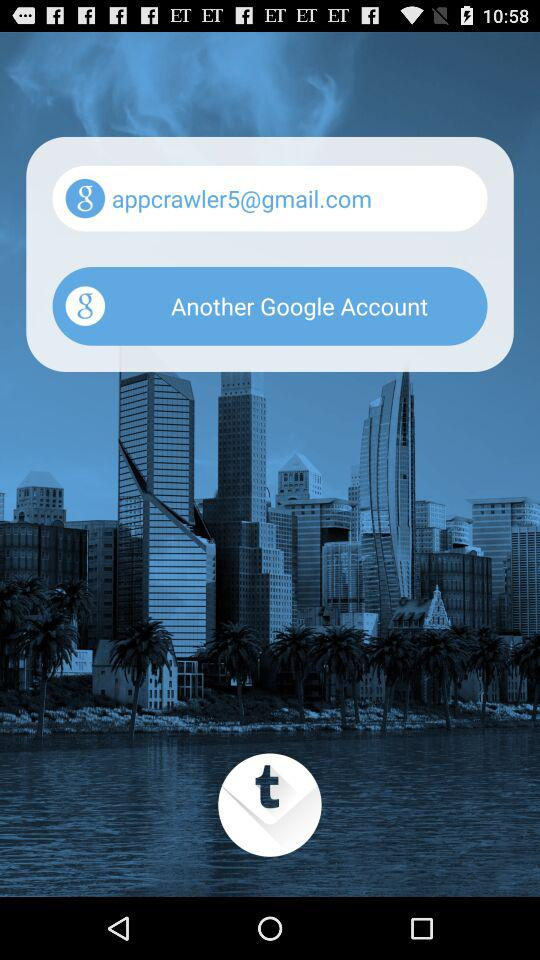What is the email address? The email address is appcrawler5@gmail.com. 